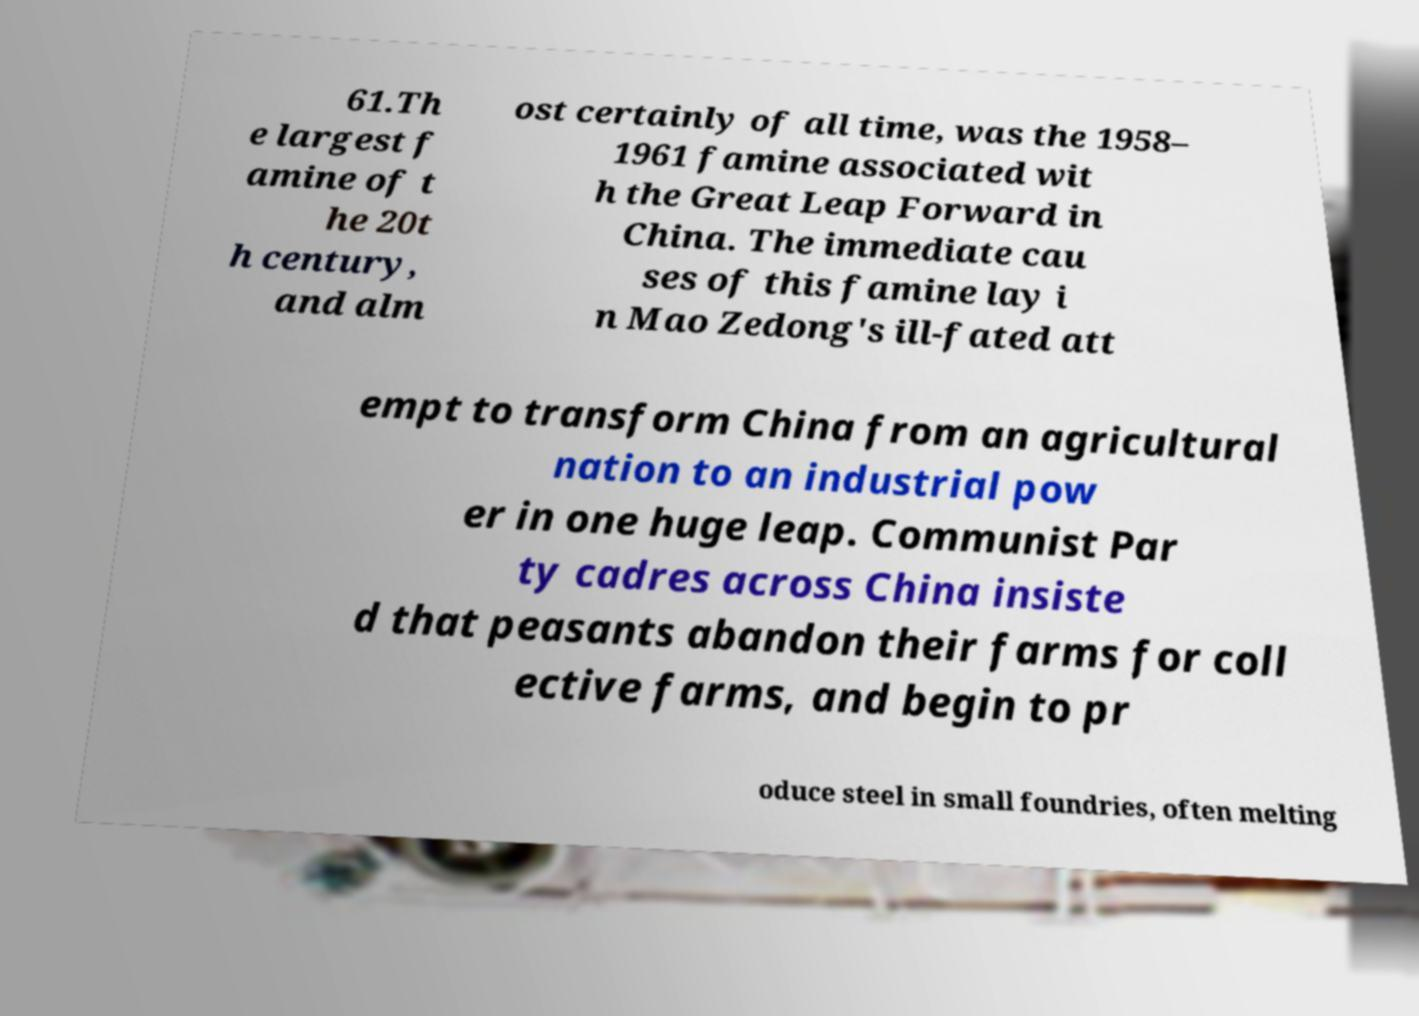Can you read and provide the text displayed in the image?This photo seems to have some interesting text. Can you extract and type it out for me? 61.Th e largest f amine of t he 20t h century, and alm ost certainly of all time, was the 1958– 1961 famine associated wit h the Great Leap Forward in China. The immediate cau ses of this famine lay i n Mao Zedong's ill-fated att empt to transform China from an agricultural nation to an industrial pow er in one huge leap. Communist Par ty cadres across China insiste d that peasants abandon their farms for coll ective farms, and begin to pr oduce steel in small foundries, often melting 